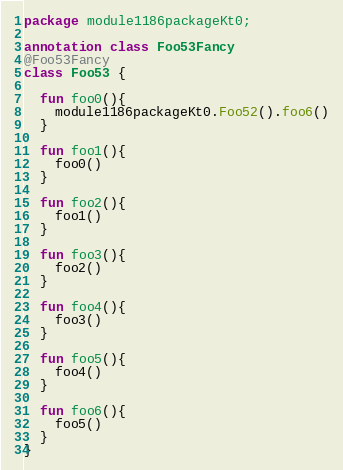<code> <loc_0><loc_0><loc_500><loc_500><_Kotlin_>package module1186packageKt0;

annotation class Foo53Fancy
@Foo53Fancy
class Foo53 {

  fun foo0(){
    module1186packageKt0.Foo52().foo6()
  }

  fun foo1(){
    foo0()
  }

  fun foo2(){
    foo1()
  }

  fun foo3(){
    foo2()
  }

  fun foo4(){
    foo3()
  }

  fun foo5(){
    foo4()
  }

  fun foo6(){
    foo5()
  }
}</code> 